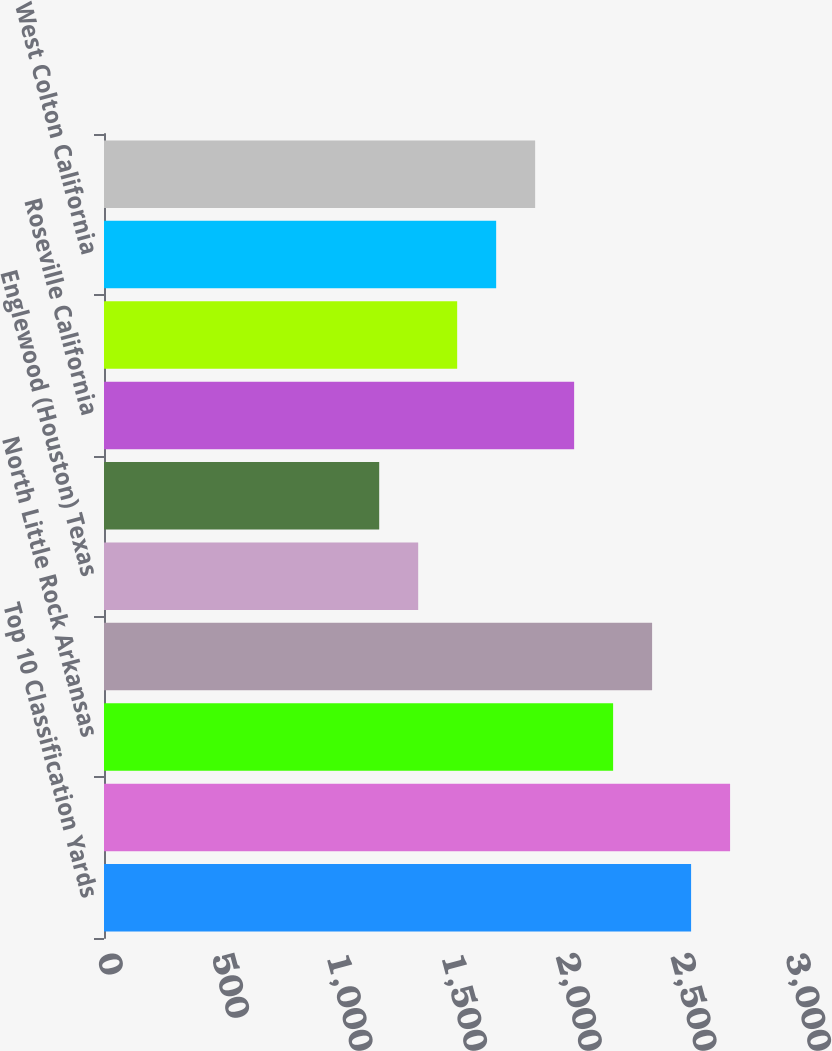Convert chart. <chart><loc_0><loc_0><loc_500><loc_500><bar_chart><fcel>Top 10 Classification Yards<fcel>North Platte Nebraska<fcel>North Little Rock Arkansas<fcel>Proviso (Chicago) Illinois<fcel>Englewood (Houston) Texas<fcel>Fort Worth Texas<fcel>Roseville California<fcel>Livonia Louisiana<fcel>West Colton California<fcel>Pine Bluff Arkansas<nl><fcel>2560<fcel>2730<fcel>2220<fcel>2390<fcel>1370<fcel>1200<fcel>2050<fcel>1540<fcel>1710<fcel>1880<nl></chart> 